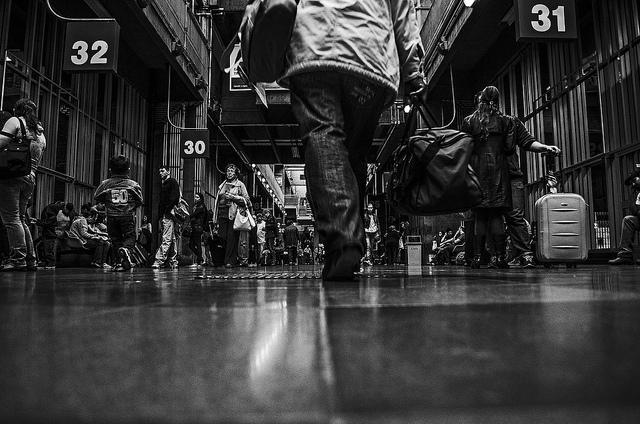Is the photo taken from the roof of a building?
Quick response, please. No. Are these people travelers?
Be succinct. Yes. Is someone injured?
Short answer required. No. What number is he?
Be succinct. 30. Do the signs have numbers on them?
Write a very short answer. Yes. Are the lights on?
Concise answer only. No. 